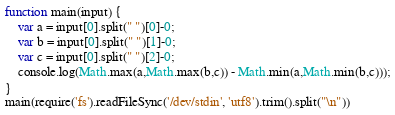Convert code to text. <code><loc_0><loc_0><loc_500><loc_500><_JavaScript_>function main(input) {
    var a = input[0].split(" ")[0]-0;
    var b = input[0].split(" ")[1]-0;
    var c = input[0].split(" ")[2]-0;
    console.log(Math.max(a,Math.max(b,c)) - Math.min(a,Math.min(b,c)));
}
main(require('fs').readFileSync('/dev/stdin', 'utf8').trim().split("\n"))
</code> 